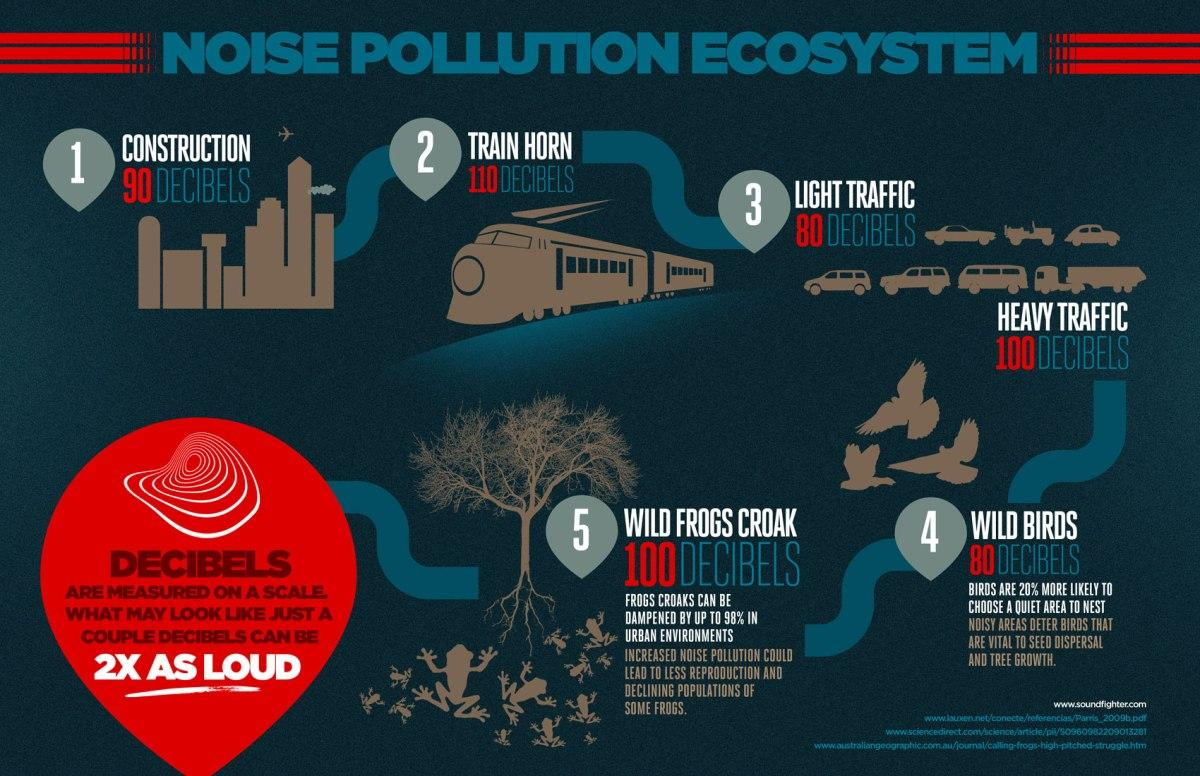Specify some key components in this picture. The noise pollution caused by construction can reach levels of 80, 90, or 110 decibels, depending on factors such as the duration and intensity of the construction activity. These levels can have a significant impact on the surrounding community, potentially causing hearing damage or other health issues. The source of the highest amount of noise pollution is trains, according to research. The main causes of 80 dB noise pollution are light traffic and wild birds. 